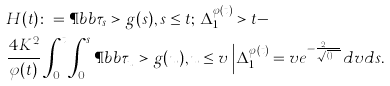<formula> <loc_0><loc_0><loc_500><loc_500>& H ( t ) \colon = \P b b { \tau _ { s } > g ( s ) , s \leq t ; \, \Delta _ { 1 } ^ { \varphi ( t ) } > t } - \\ & \frac { 4 K ^ { 2 } } { \varphi ( t ) } \int _ { 0 } ^ { t } \int _ { 0 } ^ { s } \P b b { \tau _ { u } > g ( u ) , u \leq v \, \Big | \Delta ^ { \varphi ( t ) } _ { 1 } = v } e ^ { - \frac { 2 K v } { \sqrt { \varphi ( t ) } } } d v d s .</formula> 